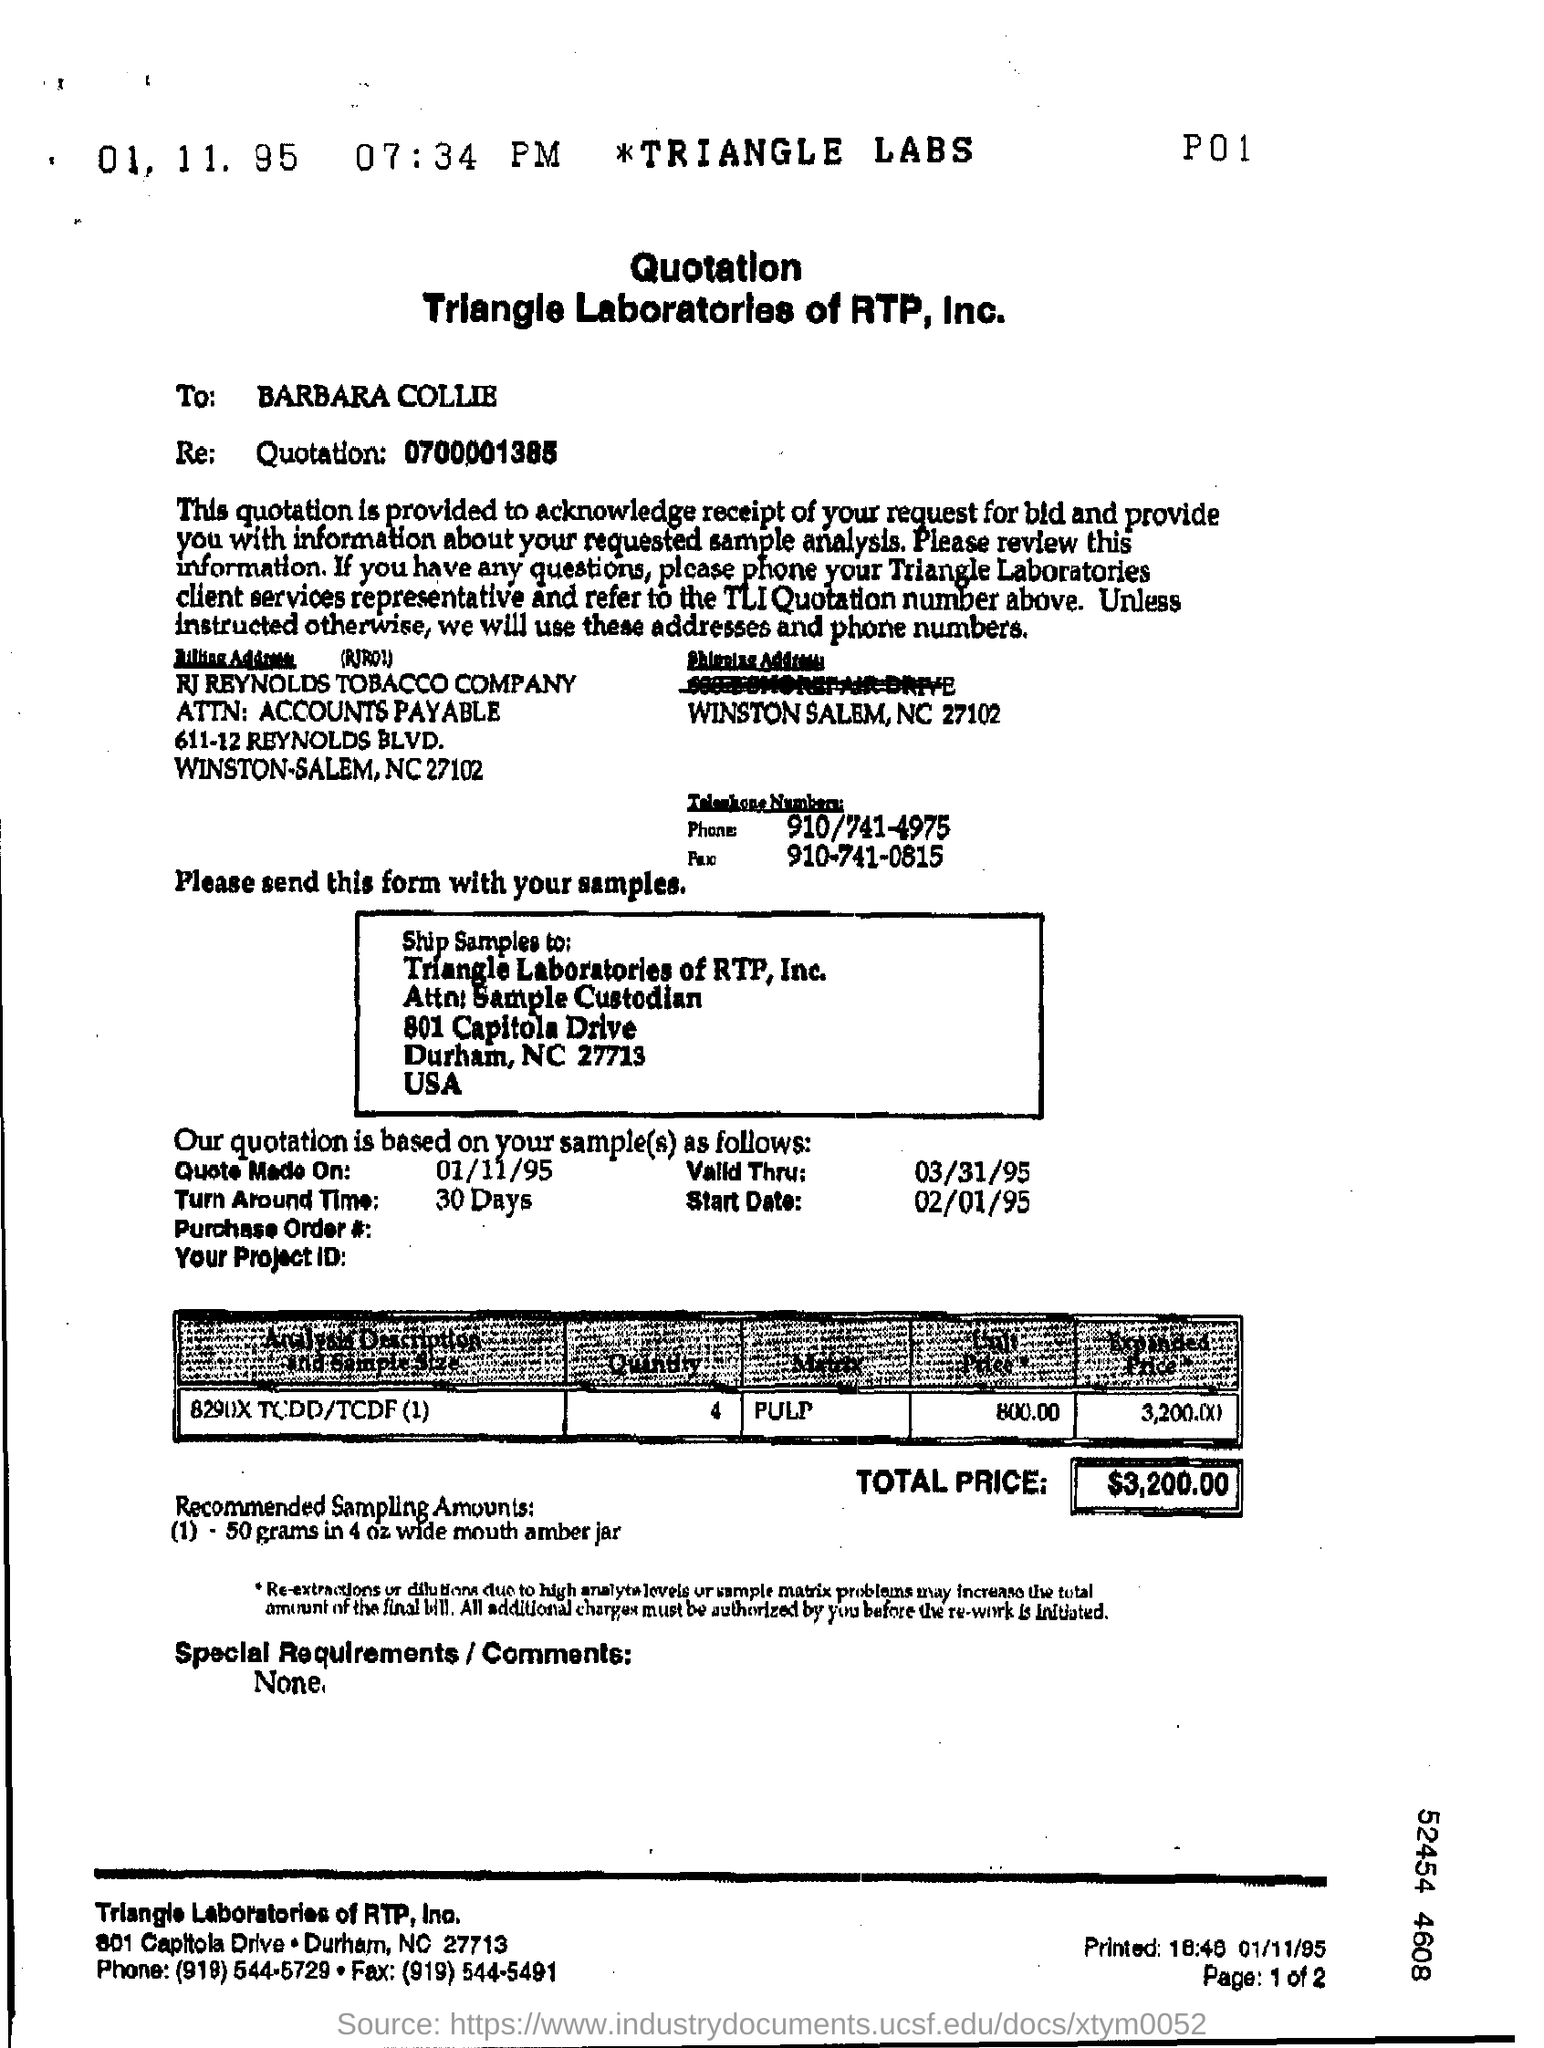Mention a couple of crucial points in this snapshot. The recommended sampling amounts for a 4 oz wide mouth amber jar containing 50 grams of material are... 